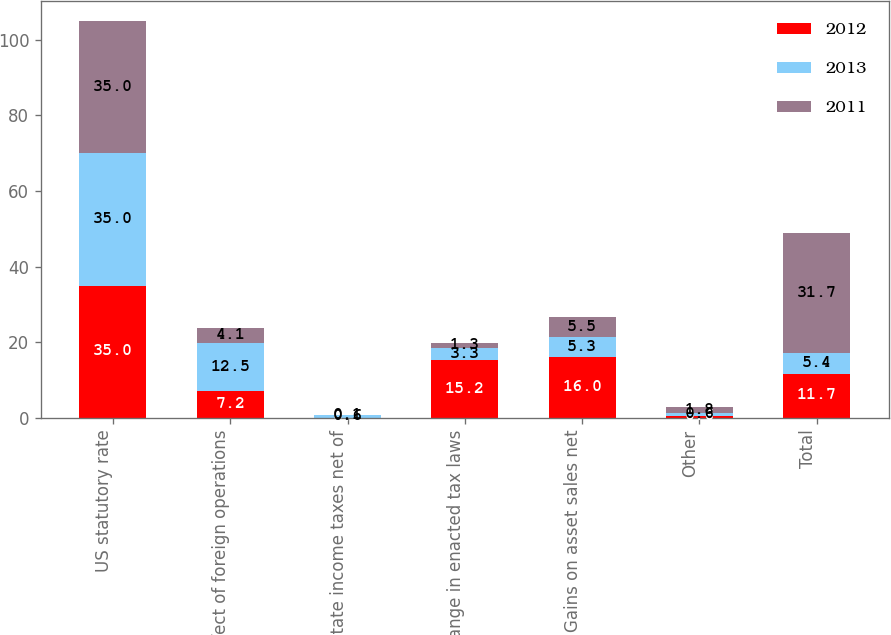Convert chart. <chart><loc_0><loc_0><loc_500><loc_500><stacked_bar_chart><ecel><fcel>US statutory rate<fcel>Effect of foreign operations<fcel>State income taxes net of<fcel>Change in enacted tax laws<fcel>Gains on asset sales net<fcel>Other<fcel>Total<nl><fcel>2012<fcel>35<fcel>7.2<fcel>0.1<fcel>15.2<fcel>16<fcel>0.6<fcel>11.7<nl><fcel>2013<fcel>35<fcel>12.5<fcel>0.6<fcel>3.3<fcel>5.3<fcel>0.6<fcel>5.4<nl><fcel>2011<fcel>35<fcel>4.1<fcel>0.1<fcel>1.3<fcel>5.5<fcel>1.8<fcel>31.7<nl></chart> 